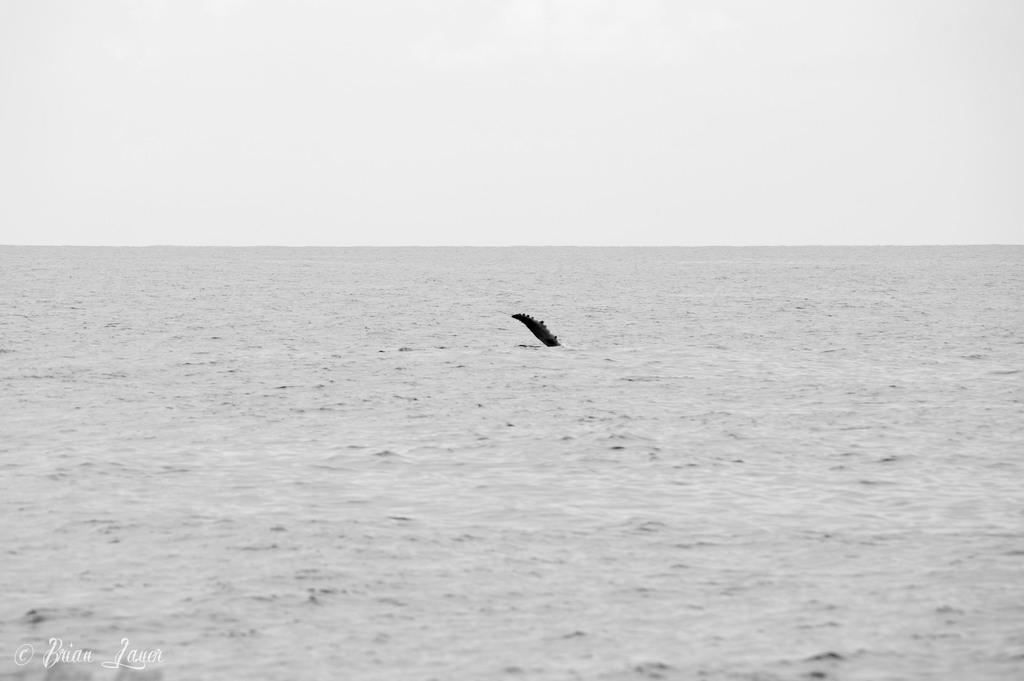Where was the image taken? The image was taken in an ocean. What can be seen at the bottom of the image? There is water at the bottom of the image. What type of animal is present in the middle of the image? There is an aquatic animal in the middle of the image. What is visible at the top of the image? The sky is visible at the top of the image. Can you see a pig swimming in the ocean in the image? No, there is no pig present in the image. The image features an aquatic animal, but it is not a pig. 